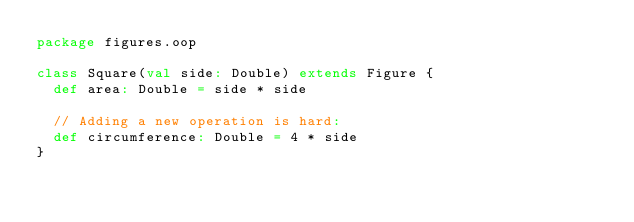<code> <loc_0><loc_0><loc_500><loc_500><_Scala_>package figures.oop

class Square(val side: Double) extends Figure {
  def area: Double = side * side

  // Adding a new operation is hard:
  def circumference: Double = 4 * side
}
</code> 